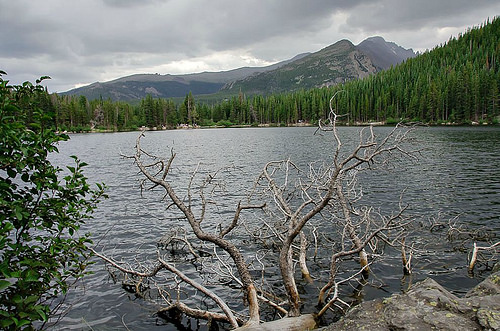<image>
Is the water in front of the trees? Yes. The water is positioned in front of the trees, appearing closer to the camera viewpoint. 